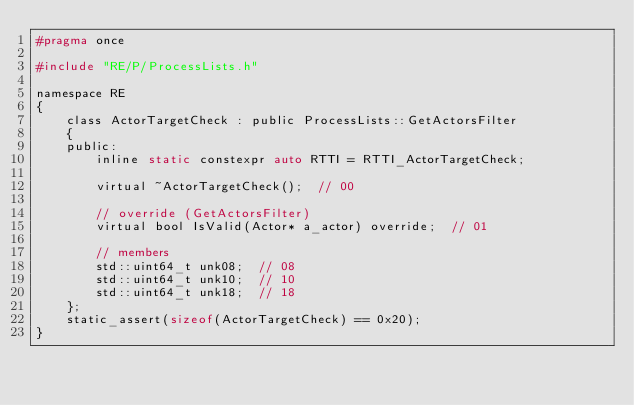Convert code to text. <code><loc_0><loc_0><loc_500><loc_500><_C_>#pragma once

#include "RE/P/ProcessLists.h"

namespace RE
{
	class ActorTargetCheck : public ProcessLists::GetActorsFilter
	{
	public:
		inline static constexpr auto RTTI = RTTI_ActorTargetCheck;

		virtual ~ActorTargetCheck();  // 00

		// override (GetActorsFilter)
		virtual bool IsValid(Actor* a_actor) override;  // 01

		// members
		std::uint64_t unk08;  // 08
		std::uint64_t unk10;  // 10
		std::uint64_t unk18;  // 18
	};
	static_assert(sizeof(ActorTargetCheck) == 0x20);
}
</code> 